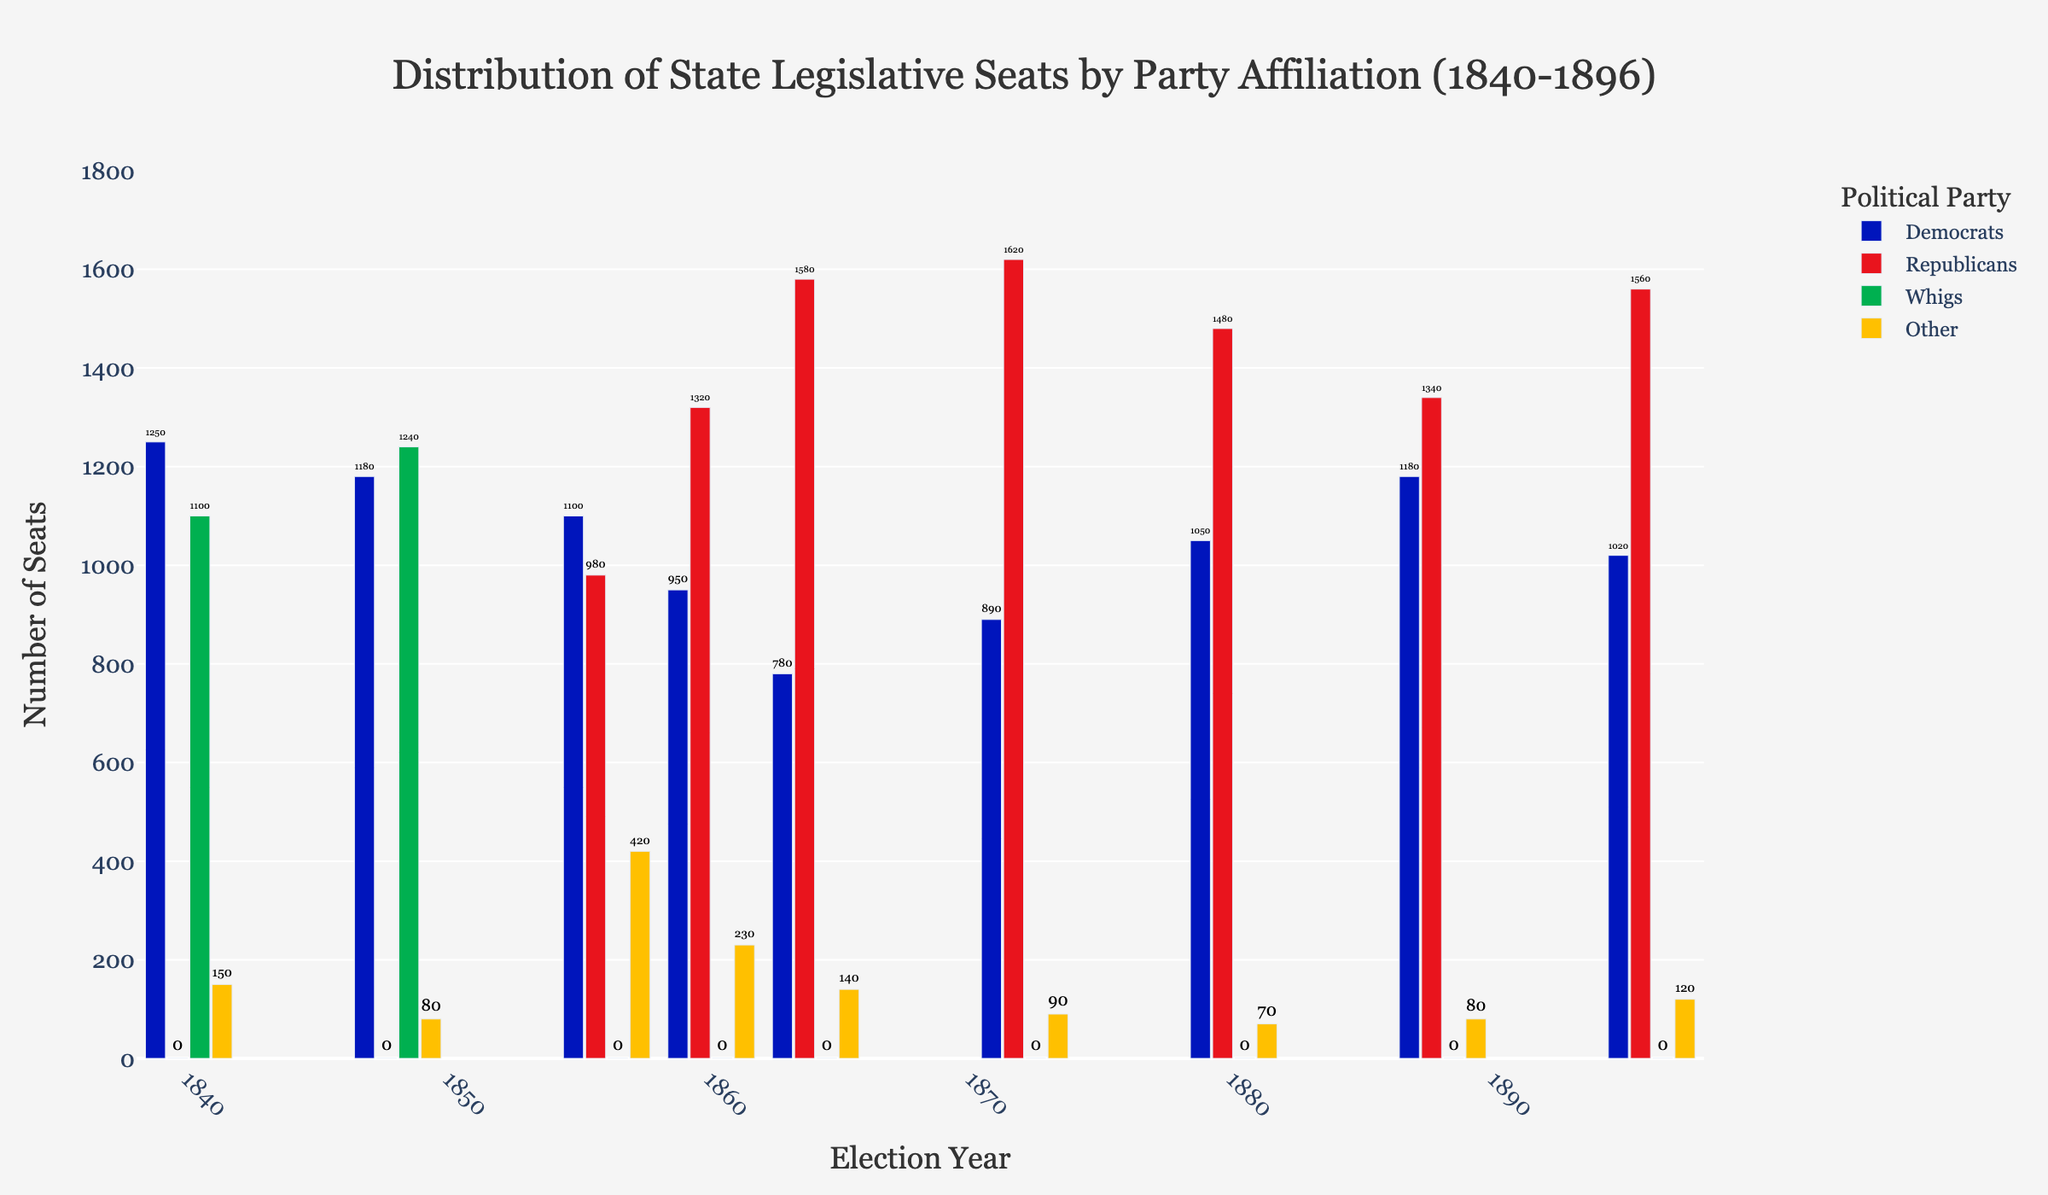Which party held the most seats in the year 1840? To determine this, observe the bar heights for each party in the year 1840. The party with the tallest bar has the most seats. Here, it's the Democrats.
Answer: Democrats How many total state legislative seats were there in 1848? Sum the number of seats for each party in 1848. Democrats had 1180, Whigs had 1240, and Other had 80. Adding them up gives 1180 + 1240 + 80 = 2500.
Answer: 2500 Between 1860 and 1864, which party saw the greatest increase in seats? Comparing the bars for each party in 1860 and 1864, notice the change in bar heights. The Republicans increased from 1320 to 1580, which is an increase of 260 seats. The Democrats decreased, and Others had minor changes. Thus, it's the Republicans.
Answer: Republicans What was the combined total of Whig and Other party seats in 1856? Sum the Whig and Other seats for 1856. The Whigs had 0 seats and Other had 420 seats. Adding them, we get 0 + 420 = 420.
Answer: 420 Which year had the smallest number of seats held by Democrats? Look for the shortest bar representing Democrats across all years. In 1864, Democrats had the shortest bar with 780 seats.
Answer: 1864 What is the difference in the number of seats held by Republicans between 1860 and 1880? Subtract the number of Republican seats in 1860 from those in 1880. Republicans had 1320 seats in 1860 and 1480 in 1880. The difference is 1480 - 1320 = 160.
Answer: 160 In which year did the 'Other' party have the highest number of seats? Identify the tallest bar for the 'Other' party across the years. The 'Other' party had the highest seats in 1856 with 420 seats.
Answer: 1856 Compare the number of seats held by Republicans and Democrats in 1896. Which party had more, and by how many? Subtract the number of Democratic seats from the Republican seats in 1896. Republicans had 1560 seats and Democrats had 1020 seats. The difference is 1560 - 1020 = 540. Republicans had more.
Answer: Republicans by 540 